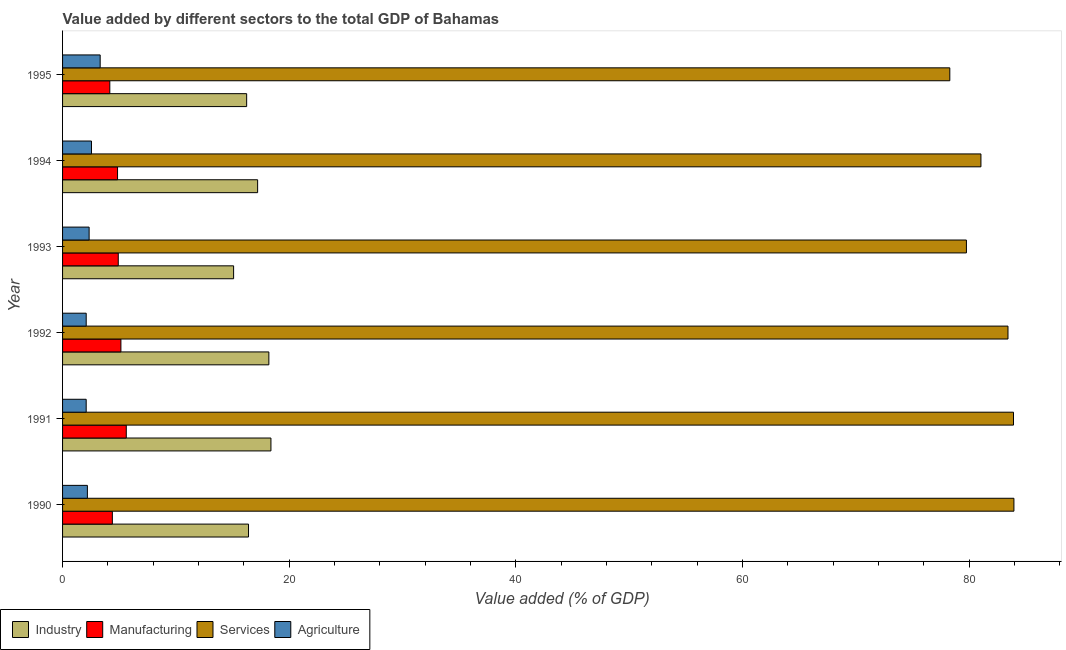Are the number of bars per tick equal to the number of legend labels?
Give a very brief answer. Yes. How many bars are there on the 4th tick from the bottom?
Offer a very short reply. 4. What is the value added by manufacturing sector in 1995?
Offer a terse response. 4.17. Across all years, what is the maximum value added by industrial sector?
Your answer should be compact. 18.39. Across all years, what is the minimum value added by services sector?
Give a very brief answer. 78.29. What is the total value added by manufacturing sector in the graph?
Ensure brevity in your answer.  29.1. What is the difference between the value added by agricultural sector in 1991 and that in 1995?
Ensure brevity in your answer.  -1.24. What is the difference between the value added by industrial sector in 1994 and the value added by agricultural sector in 1995?
Make the answer very short. 13.89. What is the average value added by industrial sector per year?
Keep it short and to the point. 16.93. In the year 1994, what is the difference between the value added by agricultural sector and value added by services sector?
Provide a short and direct response. -78.49. What is the ratio of the value added by agricultural sector in 1990 to that in 1991?
Your answer should be very brief. 1.05. What is the difference between the highest and the second highest value added by industrial sector?
Make the answer very short. 0.18. What is the difference between the highest and the lowest value added by manufacturing sector?
Your response must be concise. 1.45. Is it the case that in every year, the sum of the value added by agricultural sector and value added by services sector is greater than the sum of value added by manufacturing sector and value added by industrial sector?
Your answer should be compact. Yes. What does the 1st bar from the top in 1990 represents?
Your response must be concise. Agriculture. What does the 3rd bar from the bottom in 1991 represents?
Ensure brevity in your answer.  Services. How many years are there in the graph?
Keep it short and to the point. 6. What is the difference between two consecutive major ticks on the X-axis?
Provide a short and direct response. 20. Does the graph contain any zero values?
Your response must be concise. No. How many legend labels are there?
Offer a terse response. 4. How are the legend labels stacked?
Offer a very short reply. Horizontal. What is the title of the graph?
Keep it short and to the point. Value added by different sectors to the total GDP of Bahamas. Does "Source data assessment" appear as one of the legend labels in the graph?
Your answer should be very brief. No. What is the label or title of the X-axis?
Ensure brevity in your answer.  Value added (% of GDP). What is the label or title of the Y-axis?
Give a very brief answer. Year. What is the Value added (% of GDP) of Industry in 1990?
Ensure brevity in your answer.  16.41. What is the Value added (% of GDP) in Manufacturing in 1990?
Give a very brief answer. 4.39. What is the Value added (% of GDP) in Services in 1990?
Your response must be concise. 83.95. What is the Value added (% of GDP) of Agriculture in 1990?
Ensure brevity in your answer.  2.19. What is the Value added (% of GDP) in Industry in 1991?
Offer a very short reply. 18.39. What is the Value added (% of GDP) of Manufacturing in 1991?
Your answer should be very brief. 5.62. What is the Value added (% of GDP) in Services in 1991?
Give a very brief answer. 83.91. What is the Value added (% of GDP) of Agriculture in 1991?
Offer a very short reply. 2.08. What is the Value added (% of GDP) in Industry in 1992?
Give a very brief answer. 18.2. What is the Value added (% of GDP) of Manufacturing in 1992?
Offer a very short reply. 5.15. What is the Value added (% of GDP) in Services in 1992?
Keep it short and to the point. 83.43. What is the Value added (% of GDP) in Agriculture in 1992?
Make the answer very short. 2.09. What is the Value added (% of GDP) of Industry in 1993?
Ensure brevity in your answer.  15.09. What is the Value added (% of GDP) in Manufacturing in 1993?
Your answer should be very brief. 4.92. What is the Value added (% of GDP) in Services in 1993?
Your answer should be compact. 79.76. What is the Value added (% of GDP) in Agriculture in 1993?
Your answer should be very brief. 2.34. What is the Value added (% of GDP) in Industry in 1994?
Offer a terse response. 17.21. What is the Value added (% of GDP) of Manufacturing in 1994?
Make the answer very short. 4.85. What is the Value added (% of GDP) in Services in 1994?
Provide a succinct answer. 81.04. What is the Value added (% of GDP) in Agriculture in 1994?
Ensure brevity in your answer.  2.55. What is the Value added (% of GDP) of Industry in 1995?
Give a very brief answer. 16.24. What is the Value added (% of GDP) of Manufacturing in 1995?
Offer a terse response. 4.17. What is the Value added (% of GDP) in Services in 1995?
Provide a succinct answer. 78.29. What is the Value added (% of GDP) of Agriculture in 1995?
Provide a short and direct response. 3.32. Across all years, what is the maximum Value added (% of GDP) of Industry?
Keep it short and to the point. 18.39. Across all years, what is the maximum Value added (% of GDP) in Manufacturing?
Offer a terse response. 5.62. Across all years, what is the maximum Value added (% of GDP) in Services?
Your answer should be very brief. 83.95. Across all years, what is the maximum Value added (% of GDP) of Agriculture?
Your answer should be compact. 3.32. Across all years, what is the minimum Value added (% of GDP) in Industry?
Give a very brief answer. 15.09. Across all years, what is the minimum Value added (% of GDP) in Manufacturing?
Give a very brief answer. 4.17. Across all years, what is the minimum Value added (% of GDP) of Services?
Your response must be concise. 78.29. Across all years, what is the minimum Value added (% of GDP) in Agriculture?
Offer a very short reply. 2.08. What is the total Value added (% of GDP) in Industry in the graph?
Provide a succinct answer. 101.55. What is the total Value added (% of GDP) in Manufacturing in the graph?
Offer a terse response. 29.1. What is the total Value added (% of GDP) of Services in the graph?
Provide a short and direct response. 490.39. What is the total Value added (% of GDP) in Agriculture in the graph?
Provide a succinct answer. 14.57. What is the difference between the Value added (% of GDP) of Industry in 1990 and that in 1991?
Offer a very short reply. -1.98. What is the difference between the Value added (% of GDP) in Manufacturing in 1990 and that in 1991?
Offer a very short reply. -1.23. What is the difference between the Value added (% of GDP) of Services in 1990 and that in 1991?
Your answer should be compact. 0.04. What is the difference between the Value added (% of GDP) of Agriculture in 1990 and that in 1991?
Your response must be concise. 0.11. What is the difference between the Value added (% of GDP) in Industry in 1990 and that in 1992?
Keep it short and to the point. -1.8. What is the difference between the Value added (% of GDP) in Manufacturing in 1990 and that in 1992?
Your response must be concise. -0.75. What is the difference between the Value added (% of GDP) of Services in 1990 and that in 1992?
Offer a terse response. 0.52. What is the difference between the Value added (% of GDP) of Agriculture in 1990 and that in 1992?
Keep it short and to the point. 0.11. What is the difference between the Value added (% of GDP) in Industry in 1990 and that in 1993?
Give a very brief answer. 1.31. What is the difference between the Value added (% of GDP) in Manufacturing in 1990 and that in 1993?
Ensure brevity in your answer.  -0.52. What is the difference between the Value added (% of GDP) of Services in 1990 and that in 1993?
Make the answer very short. 4.19. What is the difference between the Value added (% of GDP) in Agriculture in 1990 and that in 1993?
Provide a short and direct response. -0.15. What is the difference between the Value added (% of GDP) of Industry in 1990 and that in 1994?
Your answer should be compact. -0.8. What is the difference between the Value added (% of GDP) in Manufacturing in 1990 and that in 1994?
Give a very brief answer. -0.46. What is the difference between the Value added (% of GDP) of Services in 1990 and that in 1994?
Your answer should be compact. 2.91. What is the difference between the Value added (% of GDP) of Agriculture in 1990 and that in 1994?
Your answer should be very brief. -0.36. What is the difference between the Value added (% of GDP) of Industry in 1990 and that in 1995?
Ensure brevity in your answer.  0.16. What is the difference between the Value added (% of GDP) of Manufacturing in 1990 and that in 1995?
Your answer should be very brief. 0.23. What is the difference between the Value added (% of GDP) of Services in 1990 and that in 1995?
Your response must be concise. 5.66. What is the difference between the Value added (% of GDP) of Agriculture in 1990 and that in 1995?
Provide a succinct answer. -1.13. What is the difference between the Value added (% of GDP) in Industry in 1991 and that in 1992?
Make the answer very short. 0.18. What is the difference between the Value added (% of GDP) of Manufacturing in 1991 and that in 1992?
Offer a terse response. 0.48. What is the difference between the Value added (% of GDP) in Services in 1991 and that in 1992?
Keep it short and to the point. 0.49. What is the difference between the Value added (% of GDP) in Agriculture in 1991 and that in 1992?
Make the answer very short. -0. What is the difference between the Value added (% of GDP) in Industry in 1991 and that in 1993?
Give a very brief answer. 3.29. What is the difference between the Value added (% of GDP) of Manufacturing in 1991 and that in 1993?
Provide a succinct answer. 0.71. What is the difference between the Value added (% of GDP) of Services in 1991 and that in 1993?
Your answer should be very brief. 4.15. What is the difference between the Value added (% of GDP) of Agriculture in 1991 and that in 1993?
Offer a very short reply. -0.26. What is the difference between the Value added (% of GDP) of Industry in 1991 and that in 1994?
Offer a very short reply. 1.17. What is the difference between the Value added (% of GDP) of Manufacturing in 1991 and that in 1994?
Your answer should be compact. 0.77. What is the difference between the Value added (% of GDP) in Services in 1991 and that in 1994?
Offer a very short reply. 2.87. What is the difference between the Value added (% of GDP) in Agriculture in 1991 and that in 1994?
Offer a terse response. -0.47. What is the difference between the Value added (% of GDP) of Industry in 1991 and that in 1995?
Make the answer very short. 2.14. What is the difference between the Value added (% of GDP) in Manufacturing in 1991 and that in 1995?
Your answer should be compact. 1.45. What is the difference between the Value added (% of GDP) in Services in 1991 and that in 1995?
Provide a short and direct response. 5.62. What is the difference between the Value added (% of GDP) in Agriculture in 1991 and that in 1995?
Ensure brevity in your answer.  -1.23. What is the difference between the Value added (% of GDP) of Industry in 1992 and that in 1993?
Ensure brevity in your answer.  3.11. What is the difference between the Value added (% of GDP) of Manufacturing in 1992 and that in 1993?
Keep it short and to the point. 0.23. What is the difference between the Value added (% of GDP) in Services in 1992 and that in 1993?
Offer a terse response. 3.67. What is the difference between the Value added (% of GDP) in Agriculture in 1992 and that in 1993?
Keep it short and to the point. -0.26. What is the difference between the Value added (% of GDP) of Industry in 1992 and that in 1994?
Keep it short and to the point. 0.99. What is the difference between the Value added (% of GDP) of Manufacturing in 1992 and that in 1994?
Offer a terse response. 0.3. What is the difference between the Value added (% of GDP) of Services in 1992 and that in 1994?
Offer a very short reply. 2.39. What is the difference between the Value added (% of GDP) of Agriculture in 1992 and that in 1994?
Offer a very short reply. -0.47. What is the difference between the Value added (% of GDP) of Industry in 1992 and that in 1995?
Your answer should be compact. 1.96. What is the difference between the Value added (% of GDP) in Manufacturing in 1992 and that in 1995?
Give a very brief answer. 0.98. What is the difference between the Value added (% of GDP) of Services in 1992 and that in 1995?
Provide a succinct answer. 5.13. What is the difference between the Value added (% of GDP) of Agriculture in 1992 and that in 1995?
Your response must be concise. -1.23. What is the difference between the Value added (% of GDP) of Industry in 1993 and that in 1994?
Give a very brief answer. -2.12. What is the difference between the Value added (% of GDP) of Manufacturing in 1993 and that in 1994?
Offer a very short reply. 0.06. What is the difference between the Value added (% of GDP) in Services in 1993 and that in 1994?
Your answer should be compact. -1.28. What is the difference between the Value added (% of GDP) in Agriculture in 1993 and that in 1994?
Your response must be concise. -0.21. What is the difference between the Value added (% of GDP) in Industry in 1993 and that in 1995?
Your response must be concise. -1.15. What is the difference between the Value added (% of GDP) in Manufacturing in 1993 and that in 1995?
Offer a terse response. 0.75. What is the difference between the Value added (% of GDP) in Services in 1993 and that in 1995?
Provide a short and direct response. 1.47. What is the difference between the Value added (% of GDP) of Agriculture in 1993 and that in 1995?
Provide a short and direct response. -0.97. What is the difference between the Value added (% of GDP) of Manufacturing in 1994 and that in 1995?
Offer a very short reply. 0.68. What is the difference between the Value added (% of GDP) of Services in 1994 and that in 1995?
Give a very brief answer. 2.75. What is the difference between the Value added (% of GDP) in Agriculture in 1994 and that in 1995?
Offer a terse response. -0.77. What is the difference between the Value added (% of GDP) in Industry in 1990 and the Value added (% of GDP) in Manufacturing in 1991?
Offer a terse response. 10.79. What is the difference between the Value added (% of GDP) in Industry in 1990 and the Value added (% of GDP) in Services in 1991?
Make the answer very short. -67.51. What is the difference between the Value added (% of GDP) in Industry in 1990 and the Value added (% of GDP) in Agriculture in 1991?
Offer a very short reply. 14.32. What is the difference between the Value added (% of GDP) of Manufacturing in 1990 and the Value added (% of GDP) of Services in 1991?
Your response must be concise. -79.52. What is the difference between the Value added (% of GDP) of Manufacturing in 1990 and the Value added (% of GDP) of Agriculture in 1991?
Your answer should be very brief. 2.31. What is the difference between the Value added (% of GDP) of Services in 1990 and the Value added (% of GDP) of Agriculture in 1991?
Provide a short and direct response. 81.87. What is the difference between the Value added (% of GDP) in Industry in 1990 and the Value added (% of GDP) in Manufacturing in 1992?
Offer a terse response. 11.26. What is the difference between the Value added (% of GDP) of Industry in 1990 and the Value added (% of GDP) of Services in 1992?
Your answer should be compact. -67.02. What is the difference between the Value added (% of GDP) of Industry in 1990 and the Value added (% of GDP) of Agriculture in 1992?
Provide a succinct answer. 14.32. What is the difference between the Value added (% of GDP) in Manufacturing in 1990 and the Value added (% of GDP) in Services in 1992?
Provide a succinct answer. -79.03. What is the difference between the Value added (% of GDP) in Manufacturing in 1990 and the Value added (% of GDP) in Agriculture in 1992?
Your answer should be compact. 2.31. What is the difference between the Value added (% of GDP) of Services in 1990 and the Value added (% of GDP) of Agriculture in 1992?
Your answer should be very brief. 81.87. What is the difference between the Value added (% of GDP) in Industry in 1990 and the Value added (% of GDP) in Manufacturing in 1993?
Offer a very short reply. 11.49. What is the difference between the Value added (% of GDP) in Industry in 1990 and the Value added (% of GDP) in Services in 1993?
Provide a succinct answer. -63.35. What is the difference between the Value added (% of GDP) of Industry in 1990 and the Value added (% of GDP) of Agriculture in 1993?
Give a very brief answer. 14.06. What is the difference between the Value added (% of GDP) in Manufacturing in 1990 and the Value added (% of GDP) in Services in 1993?
Your response must be concise. -75.37. What is the difference between the Value added (% of GDP) of Manufacturing in 1990 and the Value added (% of GDP) of Agriculture in 1993?
Ensure brevity in your answer.  2.05. What is the difference between the Value added (% of GDP) in Services in 1990 and the Value added (% of GDP) in Agriculture in 1993?
Provide a succinct answer. 81.61. What is the difference between the Value added (% of GDP) in Industry in 1990 and the Value added (% of GDP) in Manufacturing in 1994?
Provide a succinct answer. 11.56. What is the difference between the Value added (% of GDP) in Industry in 1990 and the Value added (% of GDP) in Services in 1994?
Your answer should be compact. -64.63. What is the difference between the Value added (% of GDP) of Industry in 1990 and the Value added (% of GDP) of Agriculture in 1994?
Keep it short and to the point. 13.86. What is the difference between the Value added (% of GDP) of Manufacturing in 1990 and the Value added (% of GDP) of Services in 1994?
Your answer should be compact. -76.65. What is the difference between the Value added (% of GDP) of Manufacturing in 1990 and the Value added (% of GDP) of Agriculture in 1994?
Provide a succinct answer. 1.84. What is the difference between the Value added (% of GDP) in Services in 1990 and the Value added (% of GDP) in Agriculture in 1994?
Provide a succinct answer. 81.4. What is the difference between the Value added (% of GDP) in Industry in 1990 and the Value added (% of GDP) in Manufacturing in 1995?
Your response must be concise. 12.24. What is the difference between the Value added (% of GDP) of Industry in 1990 and the Value added (% of GDP) of Services in 1995?
Provide a succinct answer. -61.89. What is the difference between the Value added (% of GDP) in Industry in 1990 and the Value added (% of GDP) in Agriculture in 1995?
Ensure brevity in your answer.  13.09. What is the difference between the Value added (% of GDP) of Manufacturing in 1990 and the Value added (% of GDP) of Services in 1995?
Offer a very short reply. -73.9. What is the difference between the Value added (% of GDP) of Manufacturing in 1990 and the Value added (% of GDP) of Agriculture in 1995?
Offer a very short reply. 1.08. What is the difference between the Value added (% of GDP) of Services in 1990 and the Value added (% of GDP) of Agriculture in 1995?
Offer a very short reply. 80.63. What is the difference between the Value added (% of GDP) of Industry in 1991 and the Value added (% of GDP) of Manufacturing in 1992?
Ensure brevity in your answer.  13.24. What is the difference between the Value added (% of GDP) in Industry in 1991 and the Value added (% of GDP) in Services in 1992?
Keep it short and to the point. -65.04. What is the difference between the Value added (% of GDP) of Industry in 1991 and the Value added (% of GDP) of Agriculture in 1992?
Offer a very short reply. 16.3. What is the difference between the Value added (% of GDP) of Manufacturing in 1991 and the Value added (% of GDP) of Services in 1992?
Your response must be concise. -77.8. What is the difference between the Value added (% of GDP) in Manufacturing in 1991 and the Value added (% of GDP) in Agriculture in 1992?
Your response must be concise. 3.54. What is the difference between the Value added (% of GDP) of Services in 1991 and the Value added (% of GDP) of Agriculture in 1992?
Your answer should be compact. 81.83. What is the difference between the Value added (% of GDP) in Industry in 1991 and the Value added (% of GDP) in Manufacturing in 1993?
Your response must be concise. 13.47. What is the difference between the Value added (% of GDP) of Industry in 1991 and the Value added (% of GDP) of Services in 1993?
Your answer should be very brief. -61.37. What is the difference between the Value added (% of GDP) in Industry in 1991 and the Value added (% of GDP) in Agriculture in 1993?
Your response must be concise. 16.04. What is the difference between the Value added (% of GDP) in Manufacturing in 1991 and the Value added (% of GDP) in Services in 1993?
Your answer should be very brief. -74.14. What is the difference between the Value added (% of GDP) in Manufacturing in 1991 and the Value added (% of GDP) in Agriculture in 1993?
Your response must be concise. 3.28. What is the difference between the Value added (% of GDP) of Services in 1991 and the Value added (% of GDP) of Agriculture in 1993?
Offer a very short reply. 81.57. What is the difference between the Value added (% of GDP) of Industry in 1991 and the Value added (% of GDP) of Manufacturing in 1994?
Your answer should be very brief. 13.54. What is the difference between the Value added (% of GDP) in Industry in 1991 and the Value added (% of GDP) in Services in 1994?
Keep it short and to the point. -62.65. What is the difference between the Value added (% of GDP) in Industry in 1991 and the Value added (% of GDP) in Agriculture in 1994?
Keep it short and to the point. 15.84. What is the difference between the Value added (% of GDP) of Manufacturing in 1991 and the Value added (% of GDP) of Services in 1994?
Provide a short and direct response. -75.42. What is the difference between the Value added (% of GDP) in Manufacturing in 1991 and the Value added (% of GDP) in Agriculture in 1994?
Provide a succinct answer. 3.07. What is the difference between the Value added (% of GDP) of Services in 1991 and the Value added (% of GDP) of Agriculture in 1994?
Offer a terse response. 81.36. What is the difference between the Value added (% of GDP) in Industry in 1991 and the Value added (% of GDP) in Manufacturing in 1995?
Your answer should be compact. 14.22. What is the difference between the Value added (% of GDP) in Industry in 1991 and the Value added (% of GDP) in Services in 1995?
Ensure brevity in your answer.  -59.91. What is the difference between the Value added (% of GDP) in Industry in 1991 and the Value added (% of GDP) in Agriculture in 1995?
Provide a succinct answer. 15.07. What is the difference between the Value added (% of GDP) in Manufacturing in 1991 and the Value added (% of GDP) in Services in 1995?
Your answer should be very brief. -72.67. What is the difference between the Value added (% of GDP) in Manufacturing in 1991 and the Value added (% of GDP) in Agriculture in 1995?
Your answer should be compact. 2.3. What is the difference between the Value added (% of GDP) of Services in 1991 and the Value added (% of GDP) of Agriculture in 1995?
Your answer should be very brief. 80.6. What is the difference between the Value added (% of GDP) of Industry in 1992 and the Value added (% of GDP) of Manufacturing in 1993?
Your answer should be very brief. 13.29. What is the difference between the Value added (% of GDP) in Industry in 1992 and the Value added (% of GDP) in Services in 1993?
Ensure brevity in your answer.  -61.56. What is the difference between the Value added (% of GDP) of Industry in 1992 and the Value added (% of GDP) of Agriculture in 1993?
Your answer should be compact. 15.86. What is the difference between the Value added (% of GDP) in Manufacturing in 1992 and the Value added (% of GDP) in Services in 1993?
Your response must be concise. -74.61. What is the difference between the Value added (% of GDP) of Manufacturing in 1992 and the Value added (% of GDP) of Agriculture in 1993?
Offer a very short reply. 2.8. What is the difference between the Value added (% of GDP) of Services in 1992 and the Value added (% of GDP) of Agriculture in 1993?
Keep it short and to the point. 81.08. What is the difference between the Value added (% of GDP) in Industry in 1992 and the Value added (% of GDP) in Manufacturing in 1994?
Keep it short and to the point. 13.35. What is the difference between the Value added (% of GDP) in Industry in 1992 and the Value added (% of GDP) in Services in 1994?
Ensure brevity in your answer.  -62.84. What is the difference between the Value added (% of GDP) in Industry in 1992 and the Value added (% of GDP) in Agriculture in 1994?
Your response must be concise. 15.65. What is the difference between the Value added (% of GDP) of Manufacturing in 1992 and the Value added (% of GDP) of Services in 1994?
Your answer should be compact. -75.89. What is the difference between the Value added (% of GDP) in Manufacturing in 1992 and the Value added (% of GDP) in Agriculture in 1994?
Offer a terse response. 2.6. What is the difference between the Value added (% of GDP) in Services in 1992 and the Value added (% of GDP) in Agriculture in 1994?
Keep it short and to the point. 80.88. What is the difference between the Value added (% of GDP) of Industry in 1992 and the Value added (% of GDP) of Manufacturing in 1995?
Provide a succinct answer. 14.04. What is the difference between the Value added (% of GDP) in Industry in 1992 and the Value added (% of GDP) in Services in 1995?
Ensure brevity in your answer.  -60.09. What is the difference between the Value added (% of GDP) of Industry in 1992 and the Value added (% of GDP) of Agriculture in 1995?
Keep it short and to the point. 14.89. What is the difference between the Value added (% of GDP) of Manufacturing in 1992 and the Value added (% of GDP) of Services in 1995?
Your response must be concise. -73.15. What is the difference between the Value added (% of GDP) in Manufacturing in 1992 and the Value added (% of GDP) in Agriculture in 1995?
Your response must be concise. 1.83. What is the difference between the Value added (% of GDP) of Services in 1992 and the Value added (% of GDP) of Agriculture in 1995?
Ensure brevity in your answer.  80.11. What is the difference between the Value added (% of GDP) in Industry in 1993 and the Value added (% of GDP) in Manufacturing in 1994?
Give a very brief answer. 10.24. What is the difference between the Value added (% of GDP) in Industry in 1993 and the Value added (% of GDP) in Services in 1994?
Make the answer very short. -65.95. What is the difference between the Value added (% of GDP) of Industry in 1993 and the Value added (% of GDP) of Agriculture in 1994?
Keep it short and to the point. 12.54. What is the difference between the Value added (% of GDP) in Manufacturing in 1993 and the Value added (% of GDP) in Services in 1994?
Your answer should be very brief. -76.13. What is the difference between the Value added (% of GDP) in Manufacturing in 1993 and the Value added (% of GDP) in Agriculture in 1994?
Offer a very short reply. 2.36. What is the difference between the Value added (% of GDP) in Services in 1993 and the Value added (% of GDP) in Agriculture in 1994?
Your response must be concise. 77.21. What is the difference between the Value added (% of GDP) of Industry in 1993 and the Value added (% of GDP) of Manufacturing in 1995?
Provide a succinct answer. 10.92. What is the difference between the Value added (% of GDP) in Industry in 1993 and the Value added (% of GDP) in Services in 1995?
Ensure brevity in your answer.  -63.2. What is the difference between the Value added (% of GDP) of Industry in 1993 and the Value added (% of GDP) of Agriculture in 1995?
Ensure brevity in your answer.  11.77. What is the difference between the Value added (% of GDP) in Manufacturing in 1993 and the Value added (% of GDP) in Services in 1995?
Give a very brief answer. -73.38. What is the difference between the Value added (% of GDP) in Manufacturing in 1993 and the Value added (% of GDP) in Agriculture in 1995?
Your response must be concise. 1.6. What is the difference between the Value added (% of GDP) in Services in 1993 and the Value added (% of GDP) in Agriculture in 1995?
Keep it short and to the point. 76.44. What is the difference between the Value added (% of GDP) of Industry in 1994 and the Value added (% of GDP) of Manufacturing in 1995?
Your answer should be very brief. 13.04. What is the difference between the Value added (% of GDP) in Industry in 1994 and the Value added (% of GDP) in Services in 1995?
Offer a terse response. -61.08. What is the difference between the Value added (% of GDP) in Industry in 1994 and the Value added (% of GDP) in Agriculture in 1995?
Provide a short and direct response. 13.89. What is the difference between the Value added (% of GDP) of Manufacturing in 1994 and the Value added (% of GDP) of Services in 1995?
Keep it short and to the point. -73.44. What is the difference between the Value added (% of GDP) of Manufacturing in 1994 and the Value added (% of GDP) of Agriculture in 1995?
Provide a succinct answer. 1.53. What is the difference between the Value added (% of GDP) in Services in 1994 and the Value added (% of GDP) in Agriculture in 1995?
Offer a very short reply. 77.72. What is the average Value added (% of GDP) in Industry per year?
Make the answer very short. 16.93. What is the average Value added (% of GDP) in Manufacturing per year?
Keep it short and to the point. 4.85. What is the average Value added (% of GDP) in Services per year?
Your answer should be compact. 81.73. What is the average Value added (% of GDP) in Agriculture per year?
Your answer should be compact. 2.43. In the year 1990, what is the difference between the Value added (% of GDP) in Industry and Value added (% of GDP) in Manufacturing?
Your response must be concise. 12.01. In the year 1990, what is the difference between the Value added (% of GDP) in Industry and Value added (% of GDP) in Services?
Your answer should be compact. -67.54. In the year 1990, what is the difference between the Value added (% of GDP) of Industry and Value added (% of GDP) of Agriculture?
Keep it short and to the point. 14.22. In the year 1990, what is the difference between the Value added (% of GDP) of Manufacturing and Value added (% of GDP) of Services?
Offer a terse response. -79.56. In the year 1990, what is the difference between the Value added (% of GDP) in Manufacturing and Value added (% of GDP) in Agriculture?
Your answer should be very brief. 2.2. In the year 1990, what is the difference between the Value added (% of GDP) of Services and Value added (% of GDP) of Agriculture?
Give a very brief answer. 81.76. In the year 1991, what is the difference between the Value added (% of GDP) in Industry and Value added (% of GDP) in Manufacturing?
Offer a very short reply. 12.76. In the year 1991, what is the difference between the Value added (% of GDP) in Industry and Value added (% of GDP) in Services?
Make the answer very short. -65.53. In the year 1991, what is the difference between the Value added (% of GDP) in Industry and Value added (% of GDP) in Agriculture?
Your answer should be very brief. 16.3. In the year 1991, what is the difference between the Value added (% of GDP) of Manufacturing and Value added (% of GDP) of Services?
Provide a succinct answer. -78.29. In the year 1991, what is the difference between the Value added (% of GDP) in Manufacturing and Value added (% of GDP) in Agriculture?
Ensure brevity in your answer.  3.54. In the year 1991, what is the difference between the Value added (% of GDP) in Services and Value added (% of GDP) in Agriculture?
Keep it short and to the point. 81.83. In the year 1992, what is the difference between the Value added (% of GDP) of Industry and Value added (% of GDP) of Manufacturing?
Offer a very short reply. 13.06. In the year 1992, what is the difference between the Value added (% of GDP) in Industry and Value added (% of GDP) in Services?
Ensure brevity in your answer.  -65.22. In the year 1992, what is the difference between the Value added (% of GDP) of Industry and Value added (% of GDP) of Agriculture?
Ensure brevity in your answer.  16.12. In the year 1992, what is the difference between the Value added (% of GDP) in Manufacturing and Value added (% of GDP) in Services?
Ensure brevity in your answer.  -78.28. In the year 1992, what is the difference between the Value added (% of GDP) in Manufacturing and Value added (% of GDP) in Agriculture?
Ensure brevity in your answer.  3.06. In the year 1992, what is the difference between the Value added (% of GDP) in Services and Value added (% of GDP) in Agriculture?
Give a very brief answer. 81.34. In the year 1993, what is the difference between the Value added (% of GDP) of Industry and Value added (% of GDP) of Manufacturing?
Offer a terse response. 10.18. In the year 1993, what is the difference between the Value added (% of GDP) in Industry and Value added (% of GDP) in Services?
Offer a terse response. -64.67. In the year 1993, what is the difference between the Value added (% of GDP) of Industry and Value added (% of GDP) of Agriculture?
Provide a succinct answer. 12.75. In the year 1993, what is the difference between the Value added (% of GDP) in Manufacturing and Value added (% of GDP) in Services?
Offer a terse response. -74.84. In the year 1993, what is the difference between the Value added (% of GDP) of Manufacturing and Value added (% of GDP) of Agriculture?
Ensure brevity in your answer.  2.57. In the year 1993, what is the difference between the Value added (% of GDP) in Services and Value added (% of GDP) in Agriculture?
Provide a succinct answer. 77.42. In the year 1994, what is the difference between the Value added (% of GDP) of Industry and Value added (% of GDP) of Manufacturing?
Make the answer very short. 12.36. In the year 1994, what is the difference between the Value added (% of GDP) in Industry and Value added (% of GDP) in Services?
Offer a terse response. -63.83. In the year 1994, what is the difference between the Value added (% of GDP) of Industry and Value added (% of GDP) of Agriculture?
Keep it short and to the point. 14.66. In the year 1994, what is the difference between the Value added (% of GDP) in Manufacturing and Value added (% of GDP) in Services?
Your response must be concise. -76.19. In the year 1994, what is the difference between the Value added (% of GDP) of Manufacturing and Value added (% of GDP) of Agriculture?
Make the answer very short. 2.3. In the year 1994, what is the difference between the Value added (% of GDP) of Services and Value added (% of GDP) of Agriculture?
Offer a terse response. 78.49. In the year 1995, what is the difference between the Value added (% of GDP) of Industry and Value added (% of GDP) of Manufacturing?
Offer a very short reply. 12.08. In the year 1995, what is the difference between the Value added (% of GDP) of Industry and Value added (% of GDP) of Services?
Provide a short and direct response. -62.05. In the year 1995, what is the difference between the Value added (% of GDP) in Industry and Value added (% of GDP) in Agriculture?
Give a very brief answer. 12.93. In the year 1995, what is the difference between the Value added (% of GDP) of Manufacturing and Value added (% of GDP) of Services?
Provide a short and direct response. -74.12. In the year 1995, what is the difference between the Value added (% of GDP) of Manufacturing and Value added (% of GDP) of Agriculture?
Provide a succinct answer. 0.85. In the year 1995, what is the difference between the Value added (% of GDP) of Services and Value added (% of GDP) of Agriculture?
Your response must be concise. 74.97. What is the ratio of the Value added (% of GDP) of Industry in 1990 to that in 1991?
Make the answer very short. 0.89. What is the ratio of the Value added (% of GDP) in Manufacturing in 1990 to that in 1991?
Give a very brief answer. 0.78. What is the ratio of the Value added (% of GDP) in Services in 1990 to that in 1991?
Provide a succinct answer. 1. What is the ratio of the Value added (% of GDP) in Agriculture in 1990 to that in 1991?
Your response must be concise. 1.05. What is the ratio of the Value added (% of GDP) in Industry in 1990 to that in 1992?
Provide a short and direct response. 0.9. What is the ratio of the Value added (% of GDP) in Manufacturing in 1990 to that in 1992?
Ensure brevity in your answer.  0.85. What is the ratio of the Value added (% of GDP) of Agriculture in 1990 to that in 1992?
Your answer should be very brief. 1.05. What is the ratio of the Value added (% of GDP) in Industry in 1990 to that in 1993?
Provide a succinct answer. 1.09. What is the ratio of the Value added (% of GDP) of Manufacturing in 1990 to that in 1993?
Your response must be concise. 0.89. What is the ratio of the Value added (% of GDP) of Services in 1990 to that in 1993?
Ensure brevity in your answer.  1.05. What is the ratio of the Value added (% of GDP) in Agriculture in 1990 to that in 1993?
Your answer should be compact. 0.93. What is the ratio of the Value added (% of GDP) in Industry in 1990 to that in 1994?
Provide a short and direct response. 0.95. What is the ratio of the Value added (% of GDP) in Manufacturing in 1990 to that in 1994?
Give a very brief answer. 0.91. What is the ratio of the Value added (% of GDP) of Services in 1990 to that in 1994?
Make the answer very short. 1.04. What is the ratio of the Value added (% of GDP) in Agriculture in 1990 to that in 1994?
Give a very brief answer. 0.86. What is the ratio of the Value added (% of GDP) in Manufacturing in 1990 to that in 1995?
Your answer should be compact. 1.05. What is the ratio of the Value added (% of GDP) of Services in 1990 to that in 1995?
Keep it short and to the point. 1.07. What is the ratio of the Value added (% of GDP) in Agriculture in 1990 to that in 1995?
Provide a short and direct response. 0.66. What is the ratio of the Value added (% of GDP) in Industry in 1991 to that in 1992?
Your answer should be compact. 1.01. What is the ratio of the Value added (% of GDP) in Manufacturing in 1991 to that in 1992?
Ensure brevity in your answer.  1.09. What is the ratio of the Value added (% of GDP) of Services in 1991 to that in 1992?
Ensure brevity in your answer.  1.01. What is the ratio of the Value added (% of GDP) in Agriculture in 1991 to that in 1992?
Provide a short and direct response. 1. What is the ratio of the Value added (% of GDP) of Industry in 1991 to that in 1993?
Provide a succinct answer. 1.22. What is the ratio of the Value added (% of GDP) in Manufacturing in 1991 to that in 1993?
Your response must be concise. 1.14. What is the ratio of the Value added (% of GDP) in Services in 1991 to that in 1993?
Provide a short and direct response. 1.05. What is the ratio of the Value added (% of GDP) in Agriculture in 1991 to that in 1993?
Make the answer very short. 0.89. What is the ratio of the Value added (% of GDP) in Industry in 1991 to that in 1994?
Make the answer very short. 1.07. What is the ratio of the Value added (% of GDP) in Manufacturing in 1991 to that in 1994?
Offer a very short reply. 1.16. What is the ratio of the Value added (% of GDP) of Services in 1991 to that in 1994?
Offer a terse response. 1.04. What is the ratio of the Value added (% of GDP) in Agriculture in 1991 to that in 1994?
Offer a terse response. 0.82. What is the ratio of the Value added (% of GDP) in Industry in 1991 to that in 1995?
Provide a succinct answer. 1.13. What is the ratio of the Value added (% of GDP) of Manufacturing in 1991 to that in 1995?
Give a very brief answer. 1.35. What is the ratio of the Value added (% of GDP) of Services in 1991 to that in 1995?
Your answer should be very brief. 1.07. What is the ratio of the Value added (% of GDP) of Agriculture in 1991 to that in 1995?
Keep it short and to the point. 0.63. What is the ratio of the Value added (% of GDP) of Industry in 1992 to that in 1993?
Make the answer very short. 1.21. What is the ratio of the Value added (% of GDP) in Manufacturing in 1992 to that in 1993?
Ensure brevity in your answer.  1.05. What is the ratio of the Value added (% of GDP) of Services in 1992 to that in 1993?
Keep it short and to the point. 1.05. What is the ratio of the Value added (% of GDP) of Agriculture in 1992 to that in 1993?
Provide a succinct answer. 0.89. What is the ratio of the Value added (% of GDP) in Industry in 1992 to that in 1994?
Your answer should be compact. 1.06. What is the ratio of the Value added (% of GDP) of Manufacturing in 1992 to that in 1994?
Offer a very short reply. 1.06. What is the ratio of the Value added (% of GDP) of Services in 1992 to that in 1994?
Ensure brevity in your answer.  1.03. What is the ratio of the Value added (% of GDP) of Agriculture in 1992 to that in 1994?
Ensure brevity in your answer.  0.82. What is the ratio of the Value added (% of GDP) of Industry in 1992 to that in 1995?
Offer a very short reply. 1.12. What is the ratio of the Value added (% of GDP) in Manufacturing in 1992 to that in 1995?
Give a very brief answer. 1.23. What is the ratio of the Value added (% of GDP) in Services in 1992 to that in 1995?
Ensure brevity in your answer.  1.07. What is the ratio of the Value added (% of GDP) of Agriculture in 1992 to that in 1995?
Provide a succinct answer. 0.63. What is the ratio of the Value added (% of GDP) in Industry in 1993 to that in 1994?
Your answer should be compact. 0.88. What is the ratio of the Value added (% of GDP) in Services in 1993 to that in 1994?
Your response must be concise. 0.98. What is the ratio of the Value added (% of GDP) in Agriculture in 1993 to that in 1994?
Offer a terse response. 0.92. What is the ratio of the Value added (% of GDP) of Industry in 1993 to that in 1995?
Your response must be concise. 0.93. What is the ratio of the Value added (% of GDP) in Manufacturing in 1993 to that in 1995?
Your answer should be compact. 1.18. What is the ratio of the Value added (% of GDP) of Services in 1993 to that in 1995?
Your answer should be very brief. 1.02. What is the ratio of the Value added (% of GDP) of Agriculture in 1993 to that in 1995?
Provide a short and direct response. 0.71. What is the ratio of the Value added (% of GDP) in Industry in 1994 to that in 1995?
Provide a succinct answer. 1.06. What is the ratio of the Value added (% of GDP) in Manufacturing in 1994 to that in 1995?
Your answer should be very brief. 1.16. What is the ratio of the Value added (% of GDP) in Services in 1994 to that in 1995?
Provide a short and direct response. 1.04. What is the ratio of the Value added (% of GDP) of Agriculture in 1994 to that in 1995?
Your answer should be very brief. 0.77. What is the difference between the highest and the second highest Value added (% of GDP) of Industry?
Ensure brevity in your answer.  0.18. What is the difference between the highest and the second highest Value added (% of GDP) in Manufacturing?
Your answer should be very brief. 0.48. What is the difference between the highest and the second highest Value added (% of GDP) in Services?
Your answer should be very brief. 0.04. What is the difference between the highest and the second highest Value added (% of GDP) in Agriculture?
Provide a short and direct response. 0.77. What is the difference between the highest and the lowest Value added (% of GDP) in Industry?
Your answer should be compact. 3.29. What is the difference between the highest and the lowest Value added (% of GDP) in Manufacturing?
Your answer should be compact. 1.45. What is the difference between the highest and the lowest Value added (% of GDP) in Services?
Ensure brevity in your answer.  5.66. What is the difference between the highest and the lowest Value added (% of GDP) of Agriculture?
Provide a short and direct response. 1.23. 